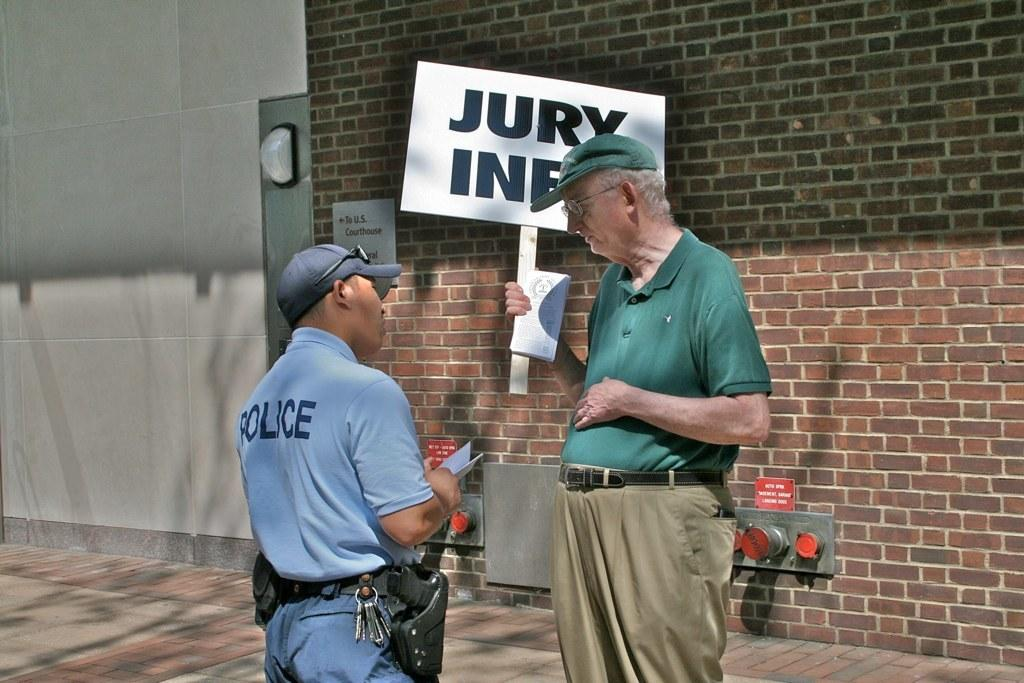What is happening in the image? There are people standing in the image. What is the man holding in the image? The man is holding a stick with a board and book. What can be seen in the background of the image? There are boards visible in the background of the image, as well as a wall. What type of belief is represented by the fork in the image? There is no fork present in the image, so it cannot be used to represent any belief. 